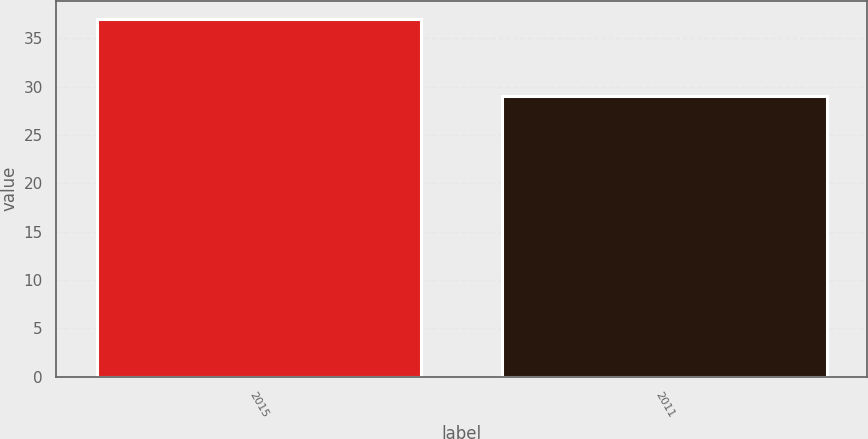<chart> <loc_0><loc_0><loc_500><loc_500><bar_chart><fcel>2015<fcel>2011<nl><fcel>37<fcel>29<nl></chart> 